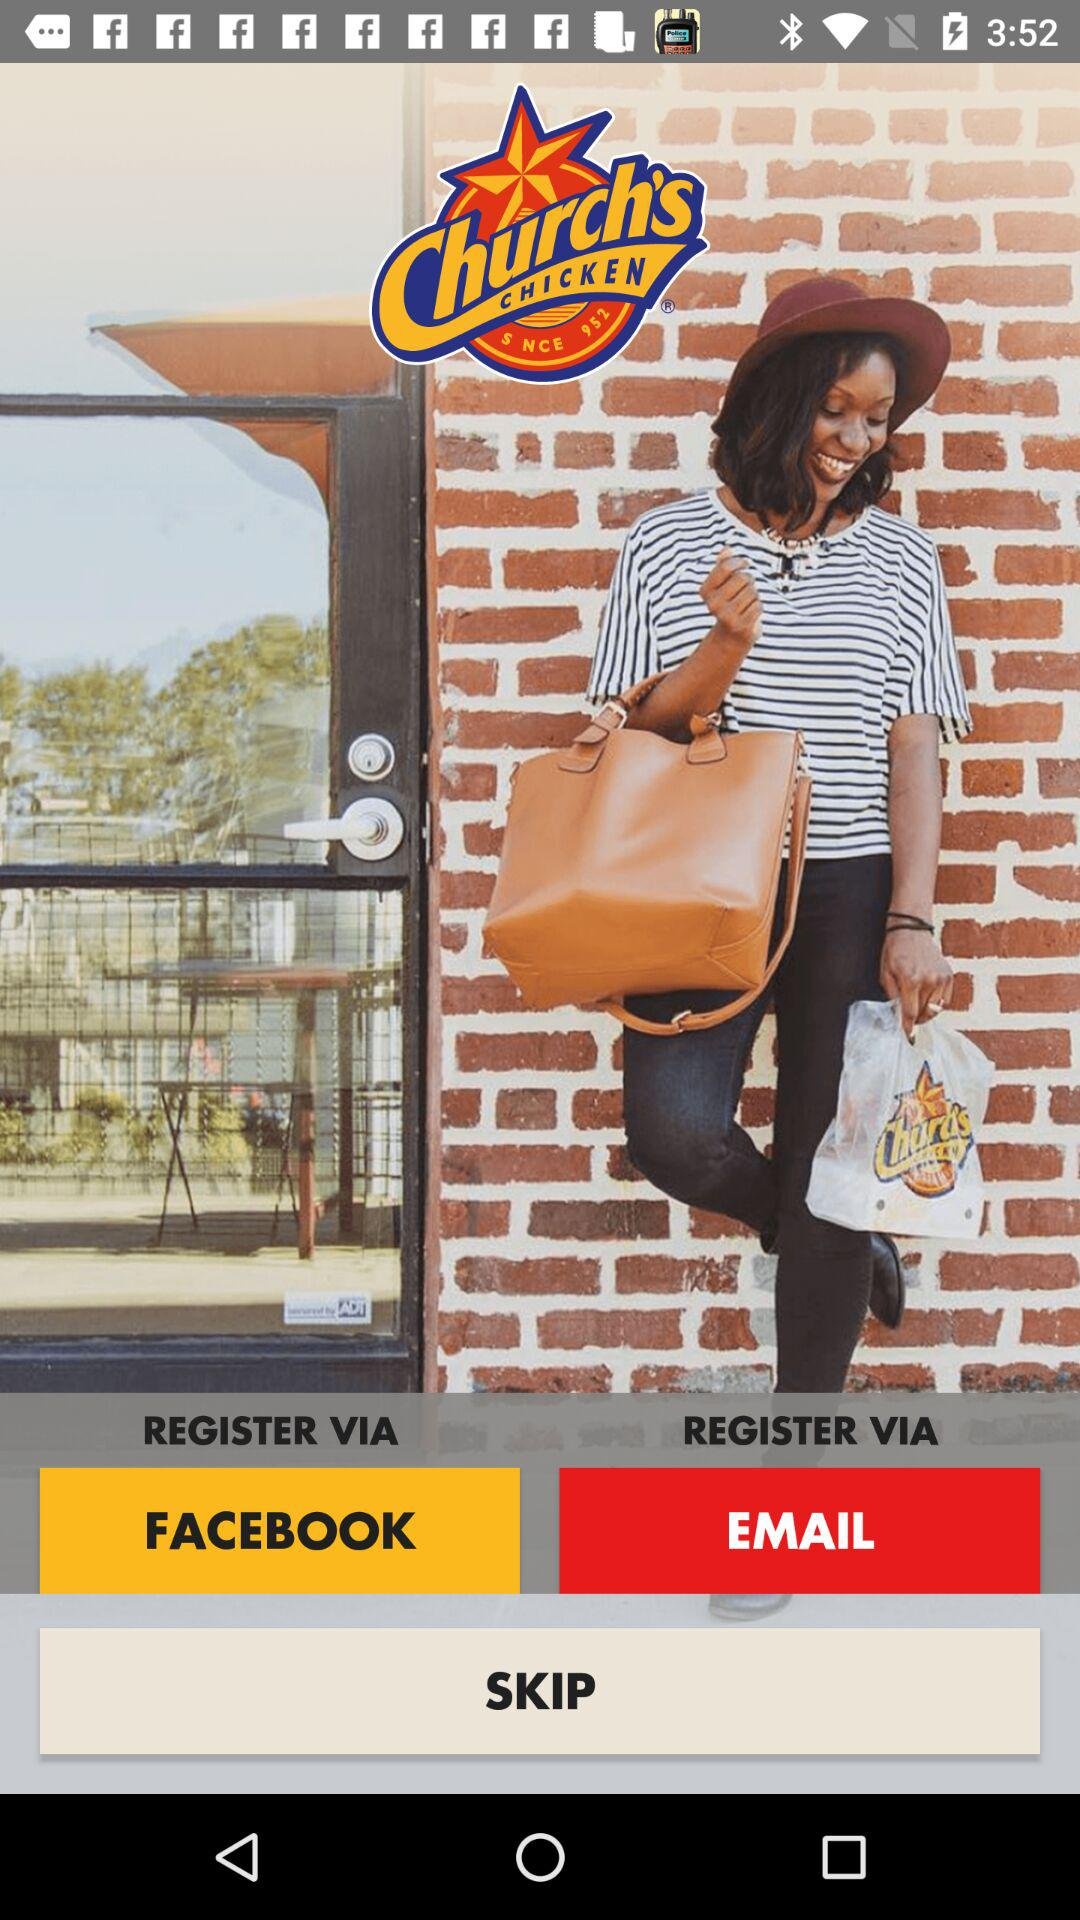Which are the different registration options? The different registration options are "FACEBOOK" and "EMAIL". 